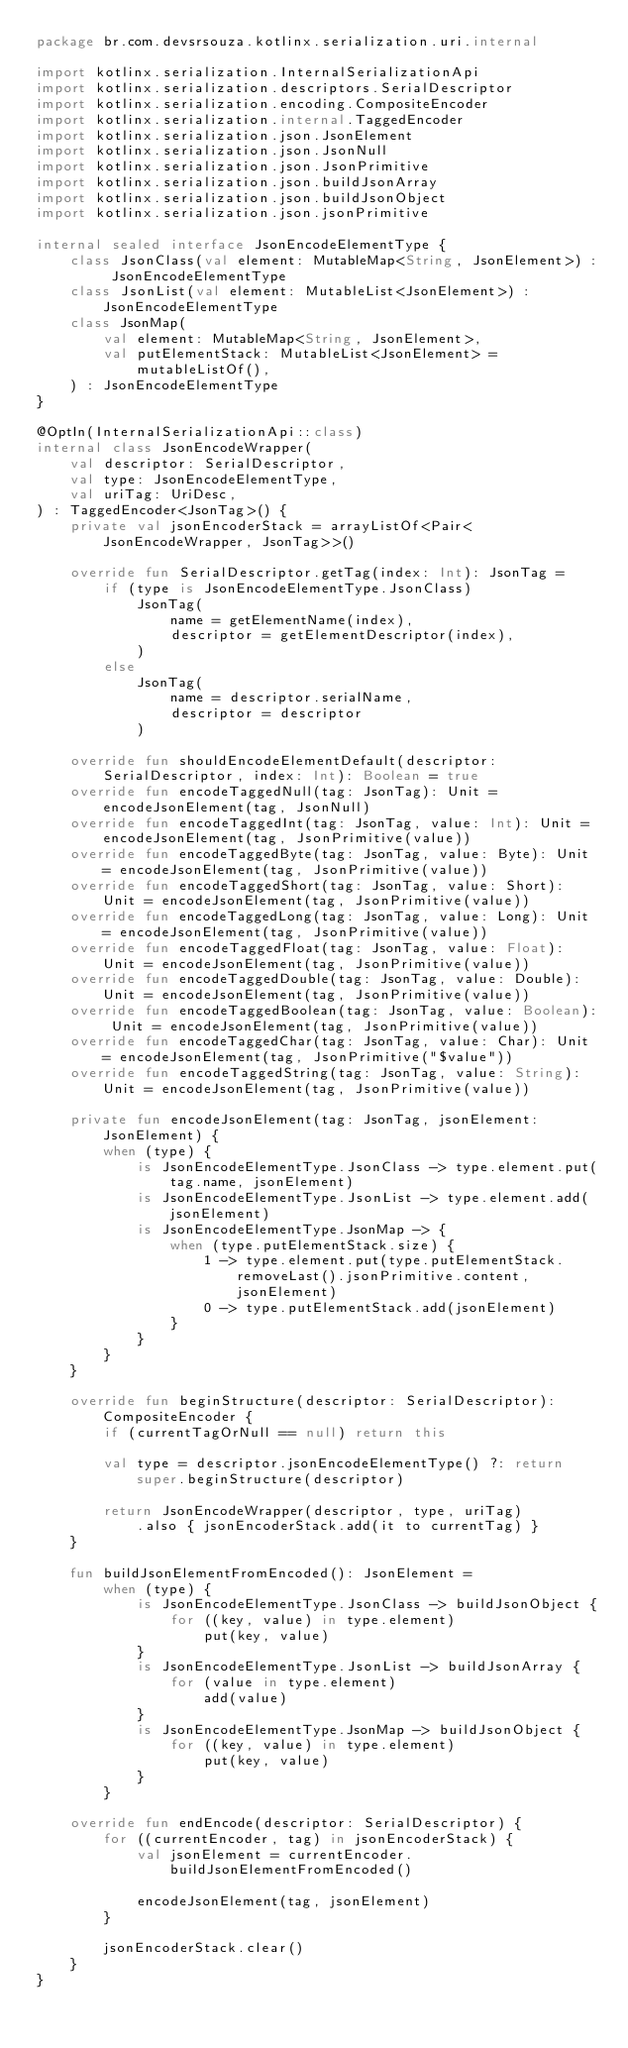Convert code to text. <code><loc_0><loc_0><loc_500><loc_500><_Kotlin_>package br.com.devsrsouza.kotlinx.serialization.uri.internal

import kotlinx.serialization.InternalSerializationApi
import kotlinx.serialization.descriptors.SerialDescriptor
import kotlinx.serialization.encoding.CompositeEncoder
import kotlinx.serialization.internal.TaggedEncoder
import kotlinx.serialization.json.JsonElement
import kotlinx.serialization.json.JsonNull
import kotlinx.serialization.json.JsonPrimitive
import kotlinx.serialization.json.buildJsonArray
import kotlinx.serialization.json.buildJsonObject
import kotlinx.serialization.json.jsonPrimitive

internal sealed interface JsonEncodeElementType {
    class JsonClass(val element: MutableMap<String, JsonElement>) : JsonEncodeElementType
    class JsonList(val element: MutableList<JsonElement>) : JsonEncodeElementType
    class JsonMap(
        val element: MutableMap<String, JsonElement>,
        val putElementStack: MutableList<JsonElement> = mutableListOf(),
    ) : JsonEncodeElementType
}

@OptIn(InternalSerializationApi::class)
internal class JsonEncodeWrapper(
    val descriptor: SerialDescriptor,
    val type: JsonEncodeElementType,
    val uriTag: UriDesc,
) : TaggedEncoder<JsonTag>() {
    private val jsonEncoderStack = arrayListOf<Pair<JsonEncodeWrapper, JsonTag>>()

    override fun SerialDescriptor.getTag(index: Int): JsonTag =
        if (type is JsonEncodeElementType.JsonClass)
            JsonTag(
                name = getElementName(index),
                descriptor = getElementDescriptor(index),
            )
        else
            JsonTag(
                name = descriptor.serialName,
                descriptor = descriptor
            )

    override fun shouldEncodeElementDefault(descriptor: SerialDescriptor, index: Int): Boolean = true
    override fun encodeTaggedNull(tag: JsonTag): Unit = encodeJsonElement(tag, JsonNull)
    override fun encodeTaggedInt(tag: JsonTag, value: Int): Unit = encodeJsonElement(tag, JsonPrimitive(value))
    override fun encodeTaggedByte(tag: JsonTag, value: Byte): Unit = encodeJsonElement(tag, JsonPrimitive(value))
    override fun encodeTaggedShort(tag: JsonTag, value: Short): Unit = encodeJsonElement(tag, JsonPrimitive(value))
    override fun encodeTaggedLong(tag: JsonTag, value: Long): Unit = encodeJsonElement(tag, JsonPrimitive(value))
    override fun encodeTaggedFloat(tag: JsonTag, value: Float): Unit = encodeJsonElement(tag, JsonPrimitive(value))
    override fun encodeTaggedDouble(tag: JsonTag, value: Double): Unit = encodeJsonElement(tag, JsonPrimitive(value))
    override fun encodeTaggedBoolean(tag: JsonTag, value: Boolean): Unit = encodeJsonElement(tag, JsonPrimitive(value))
    override fun encodeTaggedChar(tag: JsonTag, value: Char): Unit = encodeJsonElement(tag, JsonPrimitive("$value"))
    override fun encodeTaggedString(tag: JsonTag, value: String): Unit = encodeJsonElement(tag, JsonPrimitive(value))

    private fun encodeJsonElement(tag: JsonTag, jsonElement: JsonElement) {
        when (type) {
            is JsonEncodeElementType.JsonClass -> type.element.put(tag.name, jsonElement)
            is JsonEncodeElementType.JsonList -> type.element.add(jsonElement)
            is JsonEncodeElementType.JsonMap -> {
                when (type.putElementStack.size) {
                    1 -> type.element.put(type.putElementStack.removeLast().jsonPrimitive.content, jsonElement)
                    0 -> type.putElementStack.add(jsonElement)
                }
            }
        }
    }

    override fun beginStructure(descriptor: SerialDescriptor): CompositeEncoder {
        if (currentTagOrNull == null) return this

        val type = descriptor.jsonEncodeElementType() ?: return super.beginStructure(descriptor)

        return JsonEncodeWrapper(descriptor, type, uriTag)
            .also { jsonEncoderStack.add(it to currentTag) }
    }

    fun buildJsonElementFromEncoded(): JsonElement =
        when (type) {
            is JsonEncodeElementType.JsonClass -> buildJsonObject {
                for ((key, value) in type.element)
                    put(key, value)
            }
            is JsonEncodeElementType.JsonList -> buildJsonArray {
                for (value in type.element)
                    add(value)
            }
            is JsonEncodeElementType.JsonMap -> buildJsonObject {
                for ((key, value) in type.element)
                    put(key, value)
            }
        }

    override fun endEncode(descriptor: SerialDescriptor) {
        for ((currentEncoder, tag) in jsonEncoderStack) {
            val jsonElement = currentEncoder.buildJsonElementFromEncoded()

            encodeJsonElement(tag, jsonElement)
        }

        jsonEncoderStack.clear()
    }
}
</code> 